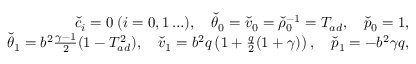Convert formula to latex. <formula><loc_0><loc_0><loc_500><loc_500>\begin{array} { r } { \check { c } _ { i } = 0 \, ( i = 0 , 1 \dots ) , \quad \check { \theta } _ { 0 } = \check { v } _ { 0 } = \check { \rho } _ { 0 } ^ { - 1 } = T _ { a d } , \quad \check { p } _ { 0 } = 1 , } \\ { \check { \theta } _ { 1 } = b ^ { 2 } \frac { \gamma - 1 } { 2 } ( 1 - T _ { a d } ^ { 2 } ) , \quad \check { v } _ { 1 } = b ^ { 2 } q \left ( 1 + \frac { q } { 2 } ( 1 + \gamma ) \right ) , \quad \check { p } _ { 1 } = - b ^ { 2 } \gamma q , } \end{array}</formula> 